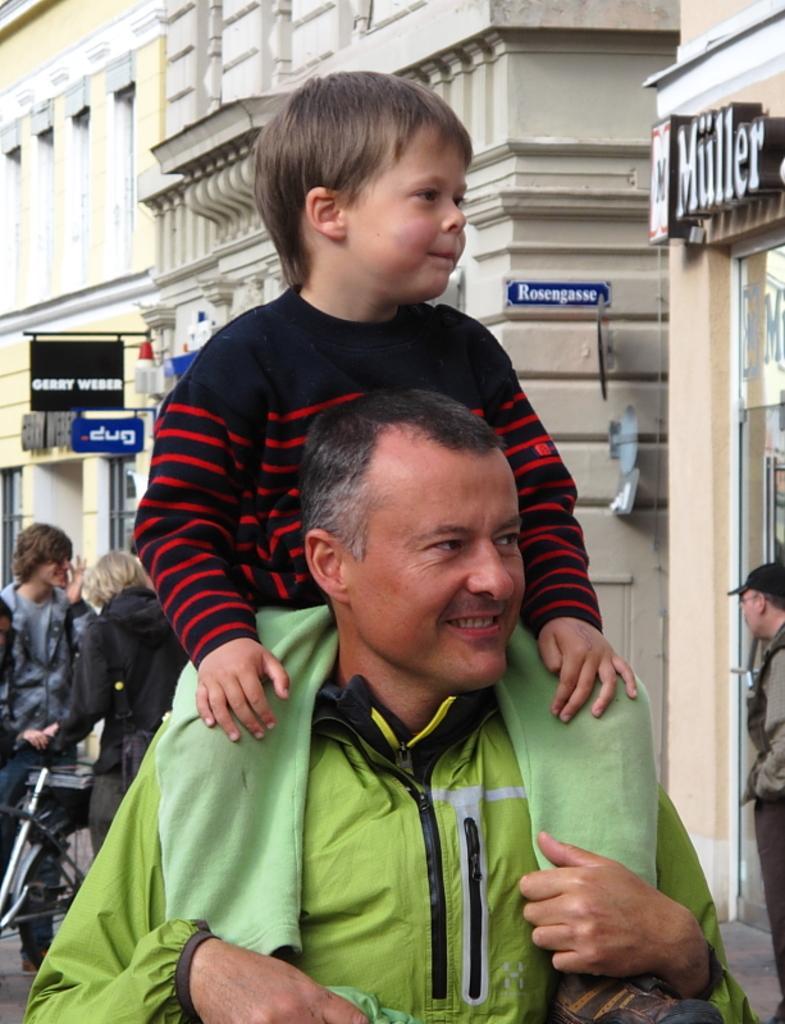In one or two sentences, can you explain what this image depicts? In this picture we can see a man carrying a kid on his shoulders & looking at someone. 